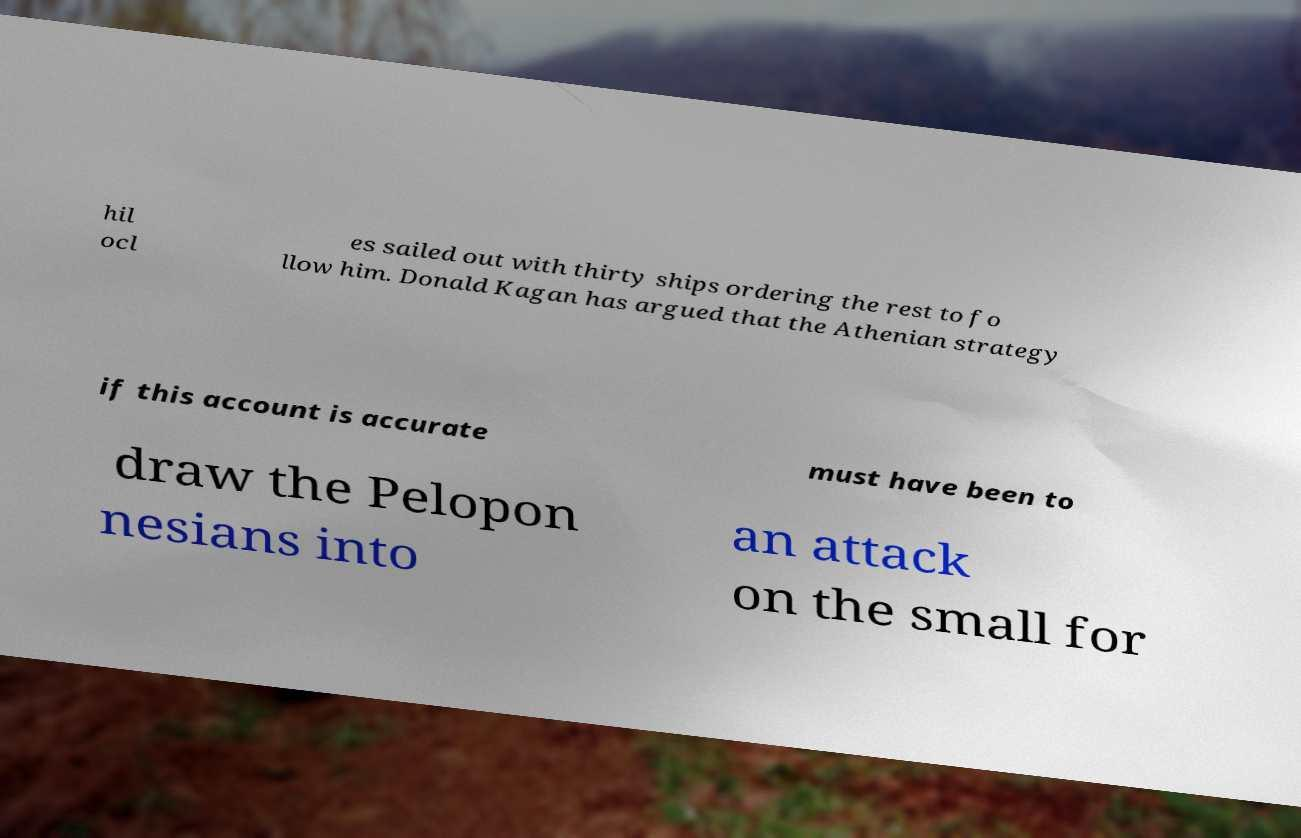Please identify and transcribe the text found in this image. hil ocl es sailed out with thirty ships ordering the rest to fo llow him. Donald Kagan has argued that the Athenian strategy if this account is accurate must have been to draw the Pelopon nesians into an attack on the small for 